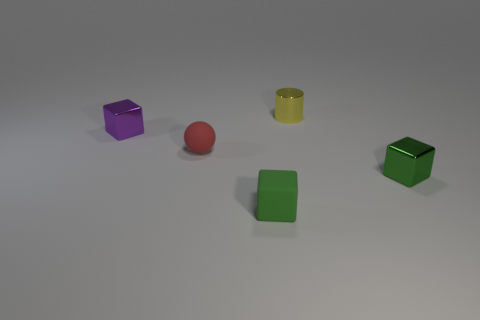Subtract all small green metallic cubes. How many cubes are left? 2 Subtract all blocks. How many objects are left? 2 Subtract all purple cubes. How many cubes are left? 2 Add 1 tiny metal objects. How many tiny metal objects are left? 4 Add 4 tiny spheres. How many tiny spheres exist? 5 Add 1 small yellow matte cylinders. How many objects exist? 6 Subtract 0 brown blocks. How many objects are left? 5 Subtract 1 cylinders. How many cylinders are left? 0 Subtract all purple cylinders. Subtract all gray cubes. How many cylinders are left? 1 Subtract all green balls. How many purple blocks are left? 1 